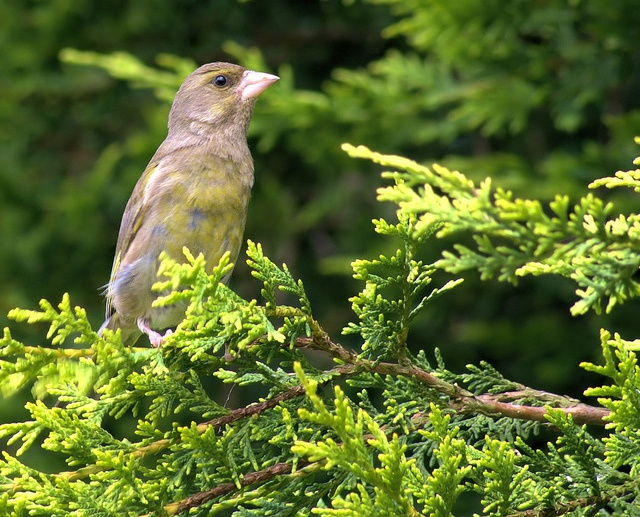Describe the objects in this image and their specific colors. I can see a bird in darkgreen, tan, darkgray, and lightgray tones in this image. 